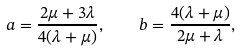Convert formula to latex. <formula><loc_0><loc_0><loc_500><loc_500>a = \frac { 2 \mu + 3 \lambda } { 4 ( \lambda + \mu ) } , \quad b = \frac { 4 ( \lambda + \mu ) } { 2 \mu + \lambda } ,</formula> 